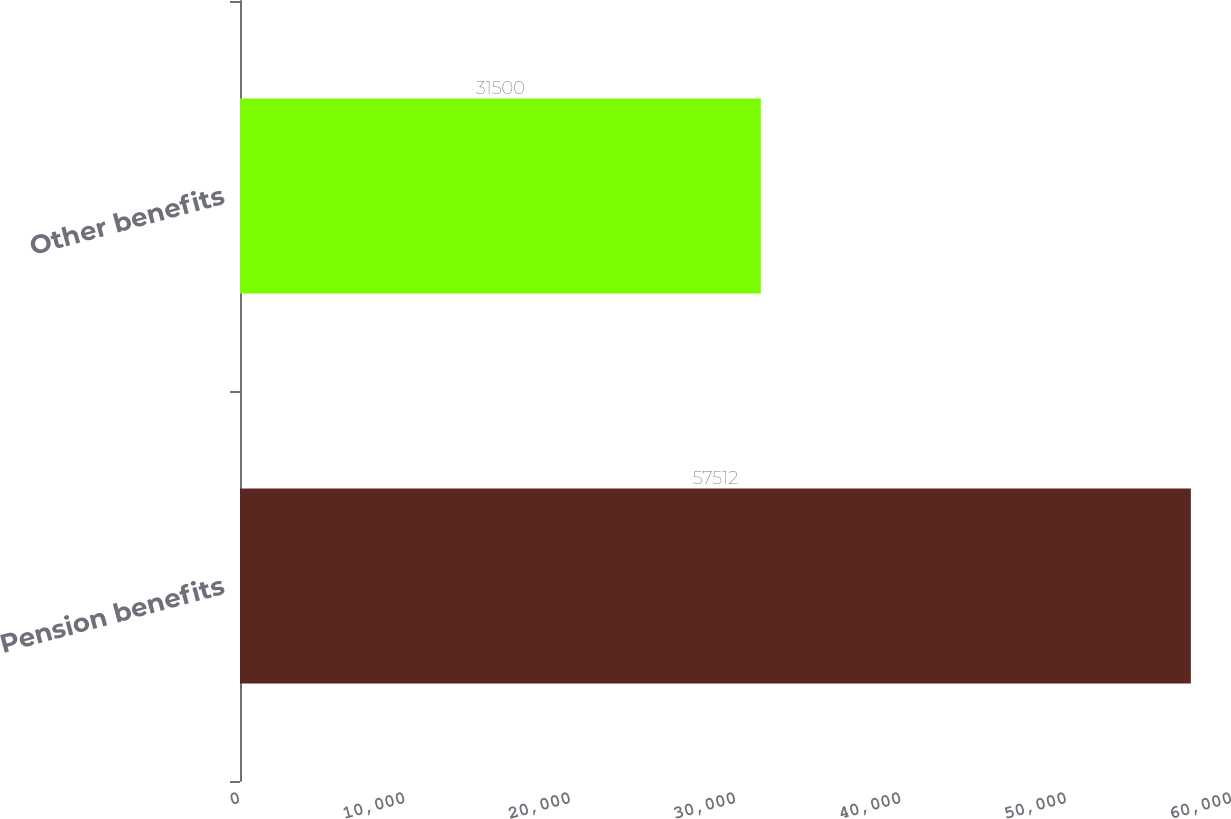Convert chart. <chart><loc_0><loc_0><loc_500><loc_500><bar_chart><fcel>Pension benefits<fcel>Other benefits<nl><fcel>57512<fcel>31500<nl></chart> 